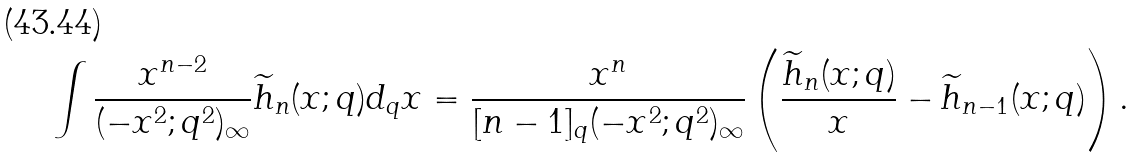Convert formula to latex. <formula><loc_0><loc_0><loc_500><loc_500>& \int \frac { x ^ { n - 2 } } { ( - x ^ { 2 } ; q ^ { 2 } ) _ { \infty } } \widetilde { h } _ { n } ( x ; q ) d _ { q } x = \frac { x ^ { n } } { [ n - 1 ] _ { q } ( - x ^ { 2 } ; q ^ { 2 } ) _ { \infty } } \left ( \frac { \widetilde { h } _ { n } ( x ; q ) } { x } - \widetilde { h } _ { n - 1 } ( x ; q ) \right ) .</formula> 